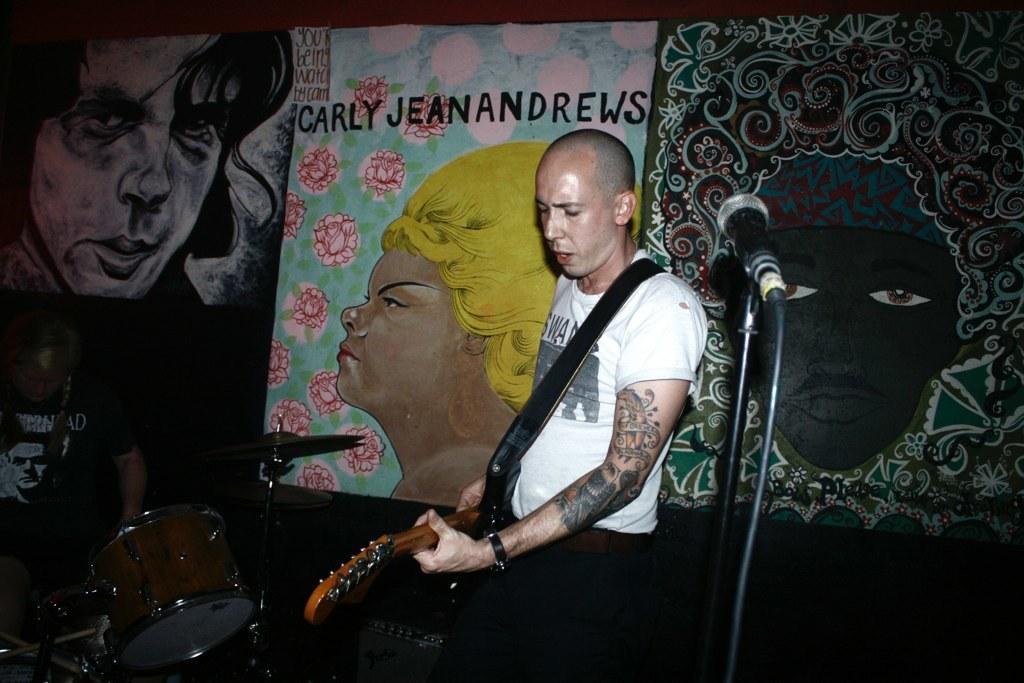Could you give a brief overview of what you see in this image? In the image we can see a person standing, wearing clothes, wrist watch and holding the guitar. Here we can see the microphone on the strand, cable wire and posters. Here we can see musical instruments and there is a person wearing clothes. 